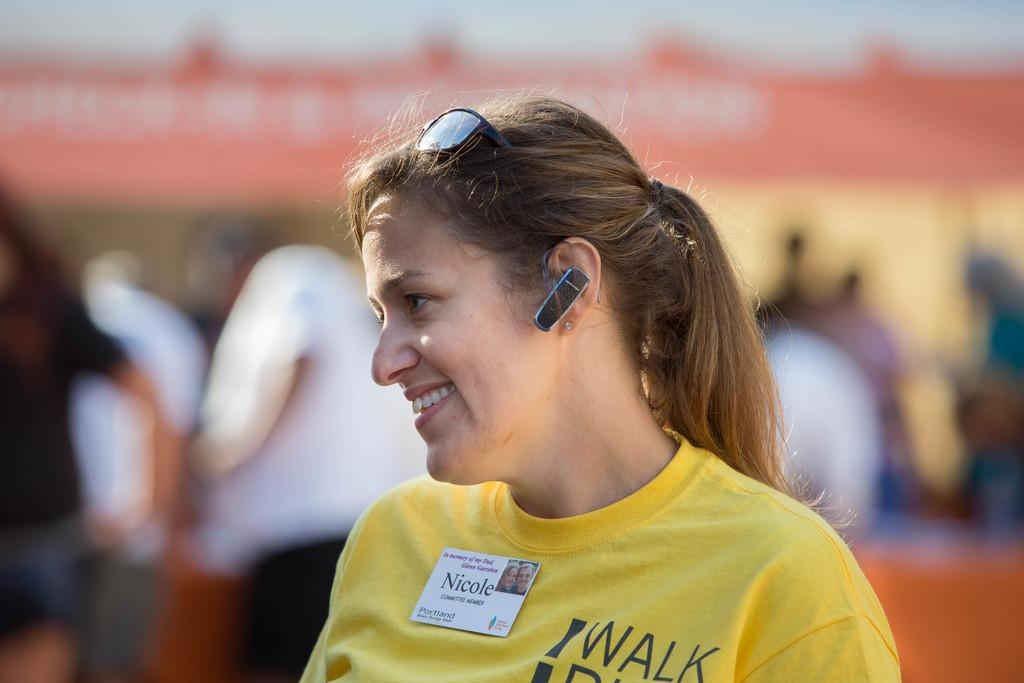Who is the main subject in the image? There is a woman in the image. What is the woman wearing? The woman is wearing a yellow shirt. What is the woman holding in the image? The woman has a batch. What device is the woman using in the image? The woman has a Bluetooth device in her ear. Can you describe the background of the image? The background is blurry, and there are people in it. What type of yam is the woman cooking in the image? There is no yam or cooking activity present in the image. What type of glass is the woman holding in the image? There is no glass present in the image. 